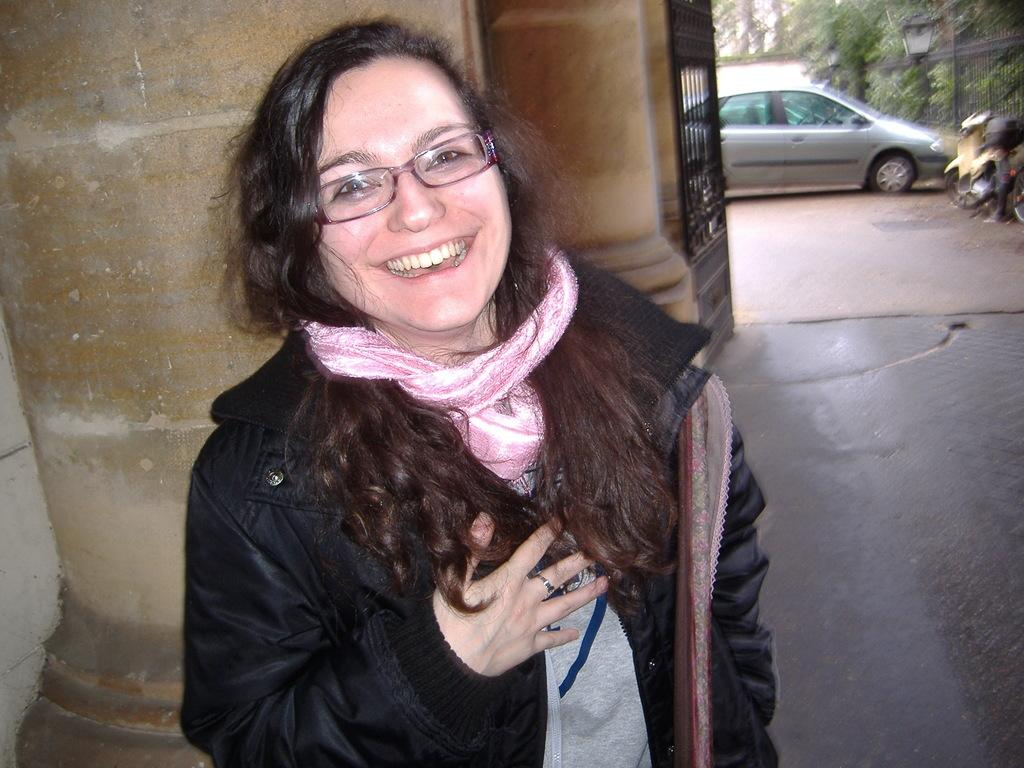Who is present in the image? There is a woman in the image. What is the woman wearing? The woman is wearing clothes and spectacles. What is the woman's facial expression? The woman is smiling. What type of surface is visible in the image? There is a floor in the image. What architectural features can be seen in the image? There is a gate, a wall, and a fence in the image. What else can be seen in the image? There are vehicles and trees in the image. What type of jail can be seen in the image? There is no jail present in the image. What type of trousers is the woman wearing in the image? The provided facts do not specify the type of trousers the woman is wearing, only that she is wearing clothes. 